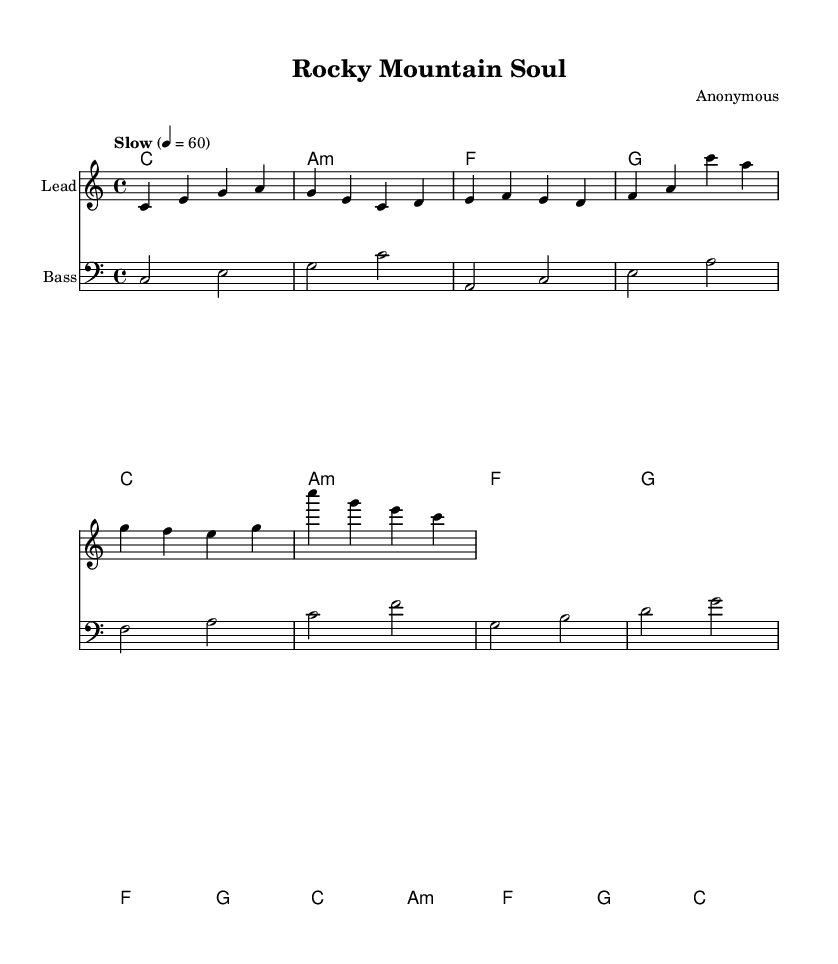What is the key signature of this music? The key signature is C major, which has no sharps or flats.
Answer: C major What is the time signature of this music? The time signature is indicated at the beginning of the sheet music as 4/4, meaning there are four beats per measure.
Answer: 4/4 What is the tempo marking in the score? The tempo marking is "Slow" with a quarter note equals 60 beats per minute, indicating a relaxed pace for the piece.
Answer: Slow How many measures are in the melody? By counting the staff lines, there are eight measures in total for the melody section of the score.
Answer: Eight Which chord follows the A minor chord in the harmony? The A minor chord is followed by an F major chord as listed in the chord progression.
Answer: F What is the overall mood that the lyrics and music are trying to convey? The lyrics express a sense of relaxation and unwinding, which is matched by the slow tempo and soothing melody, typical of soul ballads.
Answer: Relaxation Do the lyrics fit the melody's rhythm structure? Yes, the lyrics are written in a way that they align with the musical phrases, flowing naturally with the rhythm of the melody.
Answer: Yes 